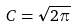<formula> <loc_0><loc_0><loc_500><loc_500>C = \sqrt { 2 \pi }</formula> 